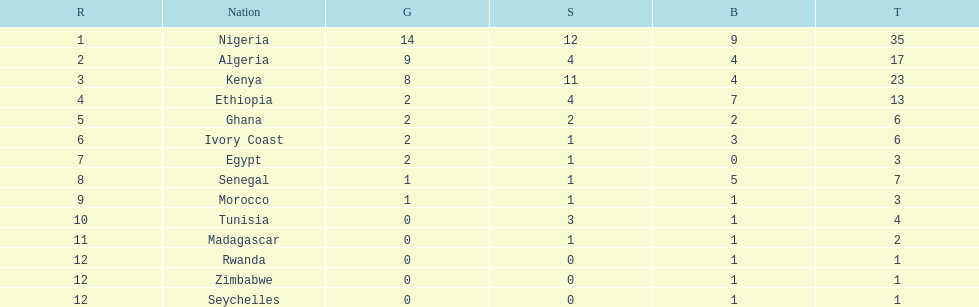What is the name of the first nation on this chart? Nigeria. Could you parse the entire table as a dict? {'header': ['R', 'Nation', 'G', 'S', 'B', 'T'], 'rows': [['1', 'Nigeria', '14', '12', '9', '35'], ['2', 'Algeria', '9', '4', '4', '17'], ['3', 'Kenya', '8', '11', '4', '23'], ['4', 'Ethiopia', '2', '4', '7', '13'], ['5', 'Ghana', '2', '2', '2', '6'], ['6', 'Ivory Coast', '2', '1', '3', '6'], ['7', 'Egypt', '2', '1', '0', '3'], ['8', 'Senegal', '1', '1', '5', '7'], ['9', 'Morocco', '1', '1', '1', '3'], ['10', 'Tunisia', '0', '3', '1', '4'], ['11', 'Madagascar', '0', '1', '1', '2'], ['12', 'Rwanda', '0', '0', '1', '1'], ['12', 'Zimbabwe', '0', '0', '1', '1'], ['12', 'Seychelles', '0', '0', '1', '1']]} 